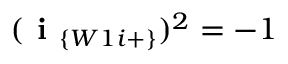Convert formula to latex. <formula><loc_0><loc_0><loc_500><loc_500>( i _ { \{ W 1 i + \} } ) ^ { 2 } = - 1</formula> 